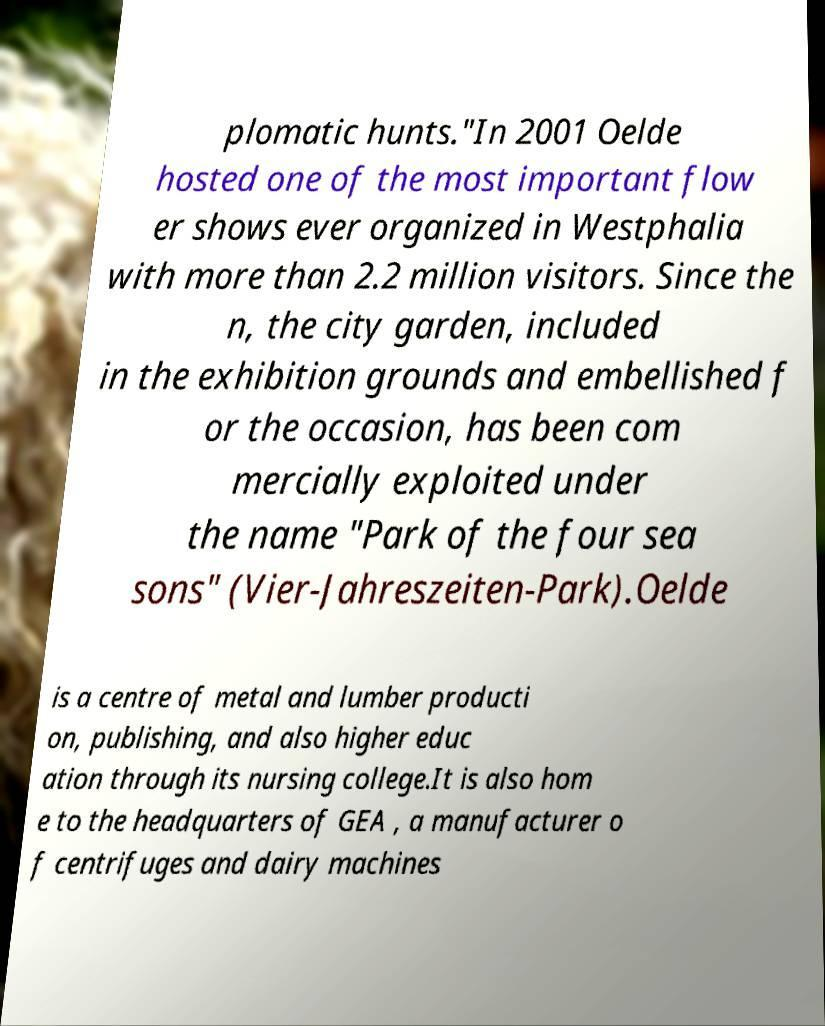What messages or text are displayed in this image? I need them in a readable, typed format. plomatic hunts."In 2001 Oelde hosted one of the most important flow er shows ever organized in Westphalia with more than 2.2 million visitors. Since the n, the city garden, included in the exhibition grounds and embellished f or the occasion, has been com mercially exploited under the name "Park of the four sea sons" (Vier-Jahreszeiten-Park).Oelde is a centre of metal and lumber producti on, publishing, and also higher educ ation through its nursing college.It is also hom e to the headquarters of GEA , a manufacturer o f centrifuges and dairy machines 